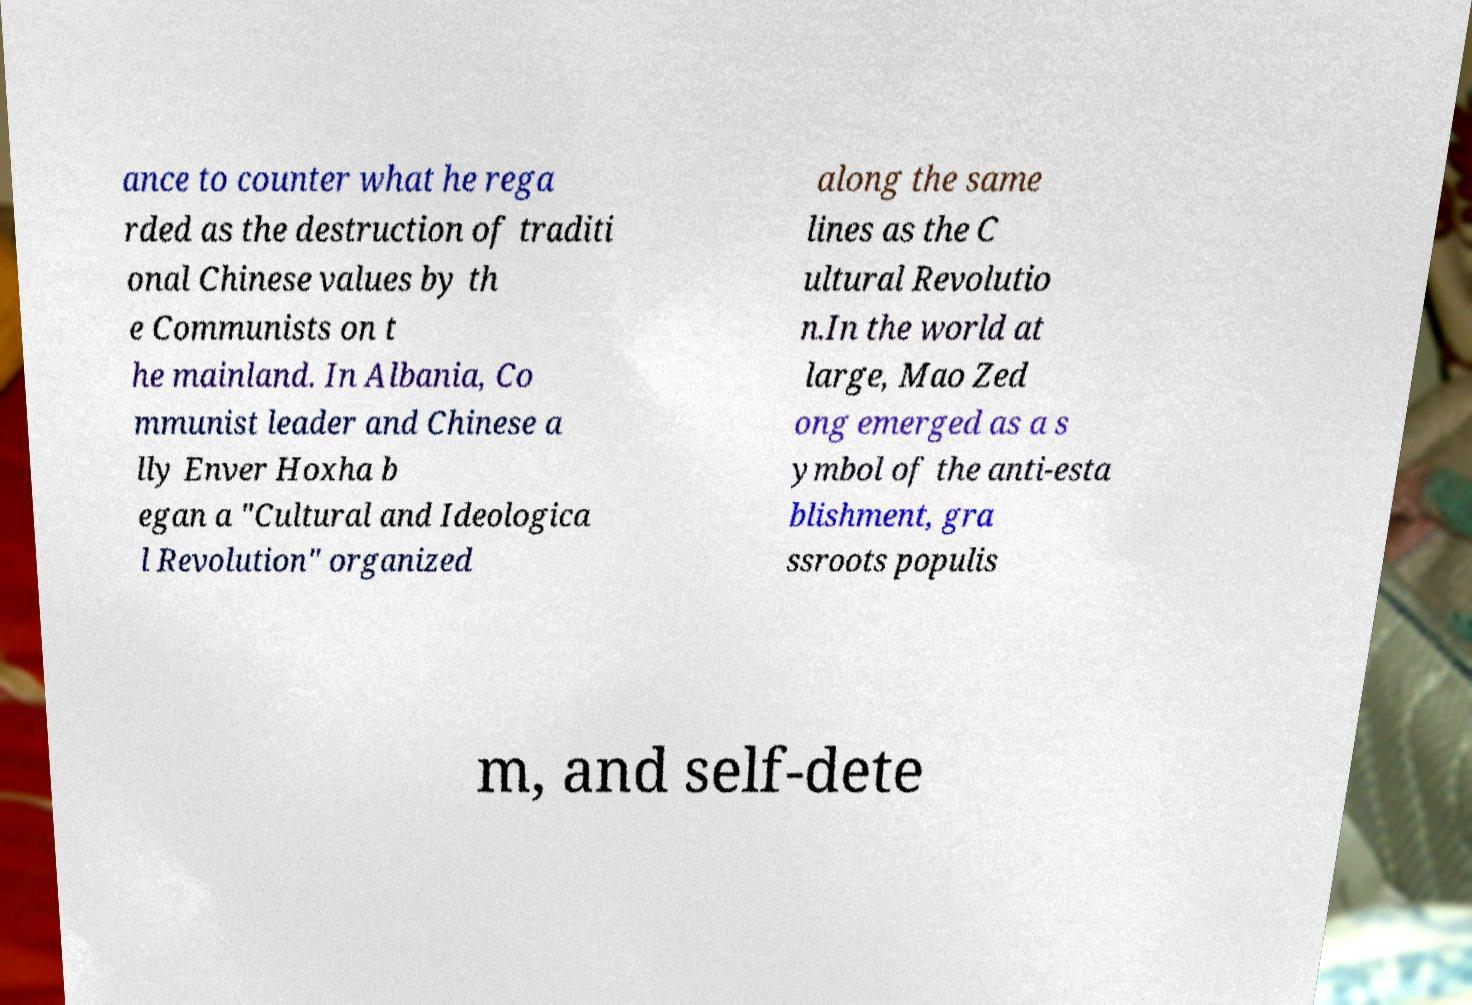Can you read and provide the text displayed in the image?This photo seems to have some interesting text. Can you extract and type it out for me? ance to counter what he rega rded as the destruction of traditi onal Chinese values by th e Communists on t he mainland. In Albania, Co mmunist leader and Chinese a lly Enver Hoxha b egan a "Cultural and Ideologica l Revolution" organized along the same lines as the C ultural Revolutio n.In the world at large, Mao Zed ong emerged as a s ymbol of the anti-esta blishment, gra ssroots populis m, and self-dete 